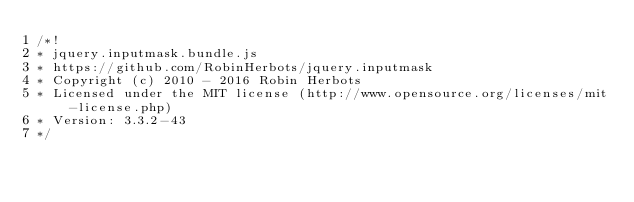Convert code to text. <code><loc_0><loc_0><loc_500><loc_500><_JavaScript_>/*!
* jquery.inputmask.bundle.js
* https://github.com/RobinHerbots/jquery.inputmask
* Copyright (c) 2010 - 2016 Robin Herbots
* Licensed under the MIT license (http://www.opensource.org/licenses/mit-license.php)
* Version: 3.3.2-43
*/</code> 